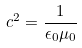<formula> <loc_0><loc_0><loc_500><loc_500>c ^ { 2 } = { \frac { 1 } { \epsilon _ { 0 } \mu _ { 0 } } }</formula> 